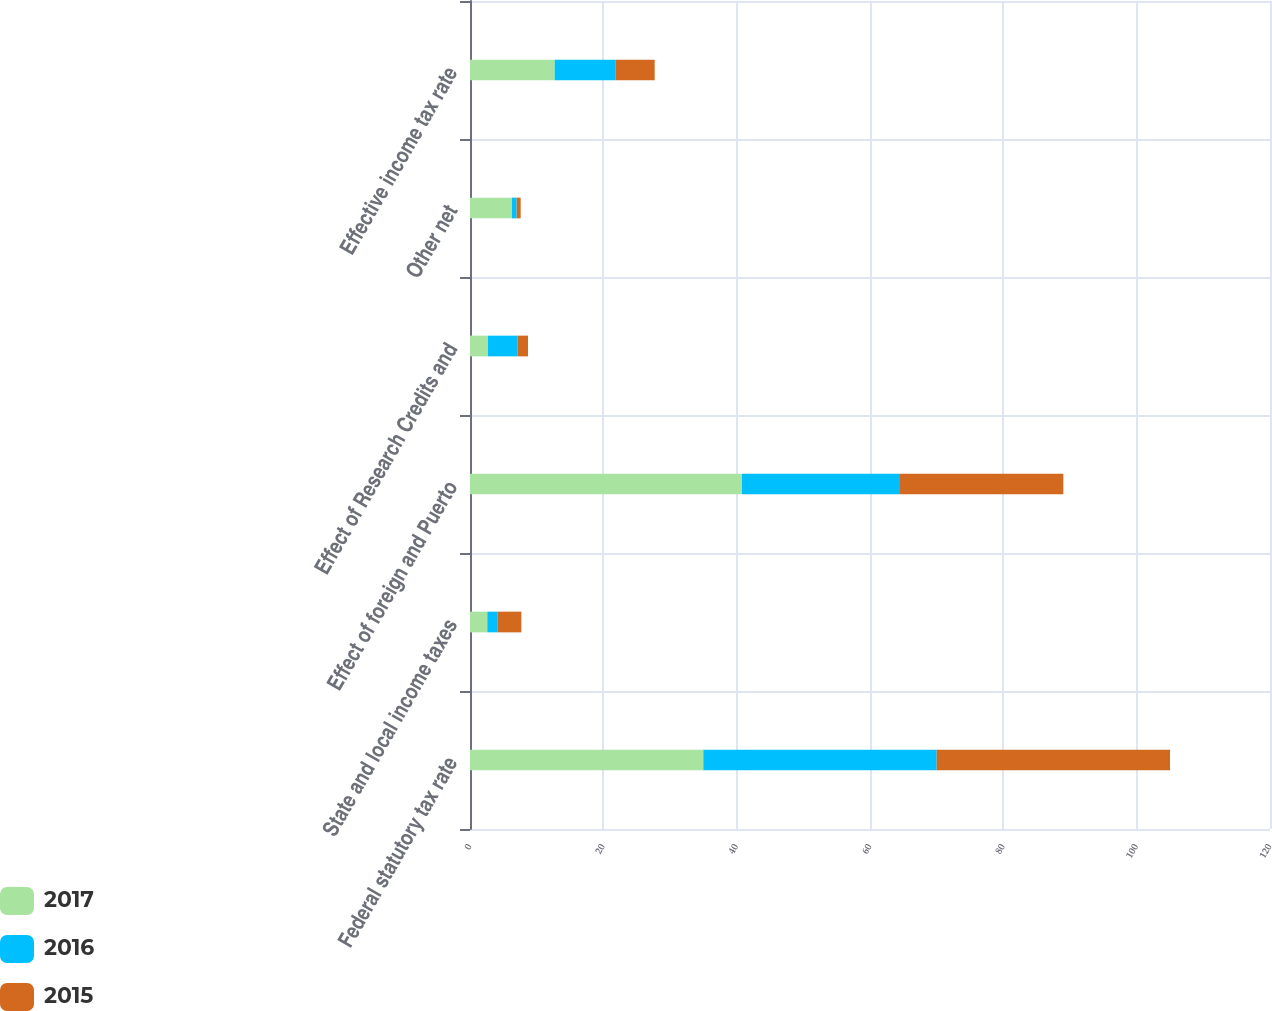Convert chart to OTSL. <chart><loc_0><loc_0><loc_500><loc_500><stacked_bar_chart><ecel><fcel>Federal statutory tax rate<fcel>State and local income taxes<fcel>Effect of foreign and Puerto<fcel>Effect of Research Credits and<fcel>Other net<fcel>Effective income tax rate<nl><fcel>2017<fcel>35<fcel>2.6<fcel>40.8<fcel>2.7<fcel>6.3<fcel>12.7<nl><fcel>2016<fcel>35<fcel>1.5<fcel>23.7<fcel>4.4<fcel>0.7<fcel>9.1<nl><fcel>2015<fcel>35<fcel>3.6<fcel>24.5<fcel>1.6<fcel>0.6<fcel>5.9<nl></chart> 